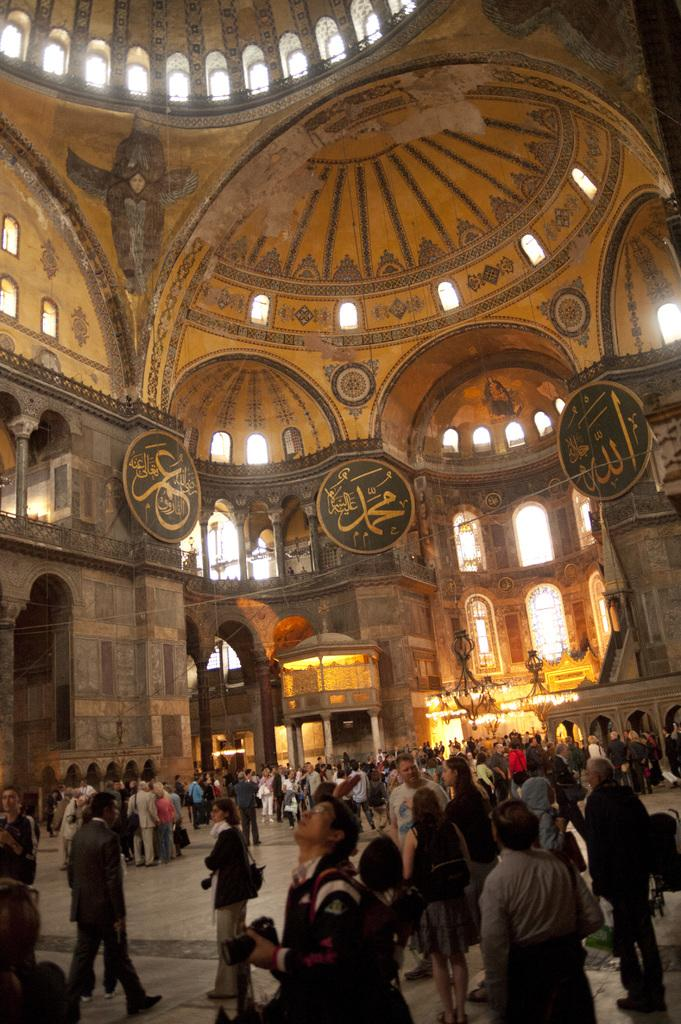What type of location is depicted in the image? The image shows an inside view of a fort. Can you describe the people in the image? There is a crowd at the bottom of the image. What architectural feature can be seen in the middle of the image? There are windows in the middle of the image. What type of story is being told by the nation in the image? There is no reference to a story or nation in the image; it depicts an inside view of a fort with a crowd and windows. 